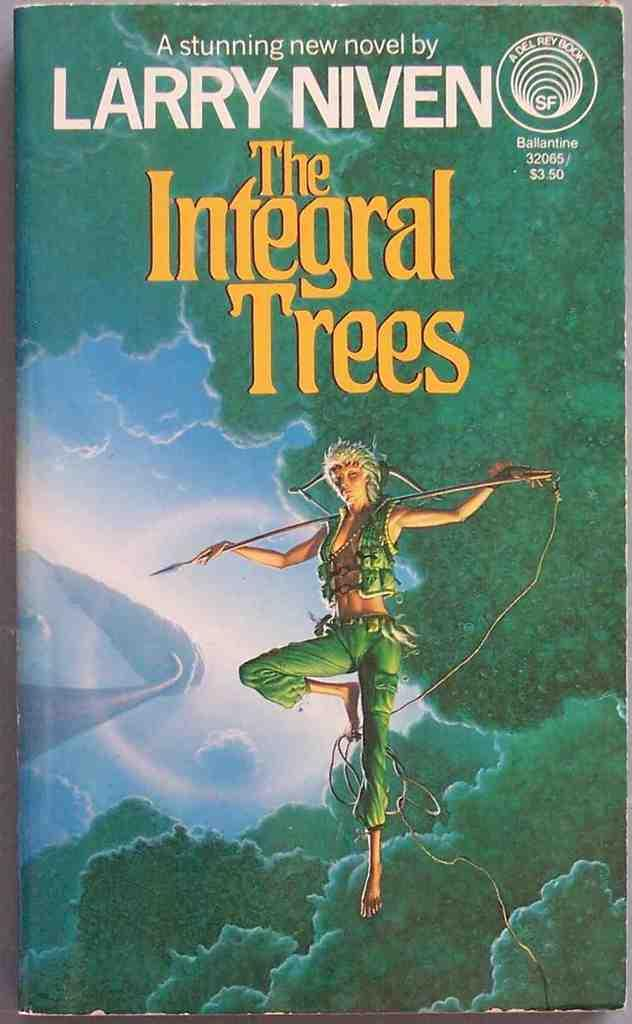<image>
Describe the image concisely. Larry Niven wrote a novel called The Integral Trees 